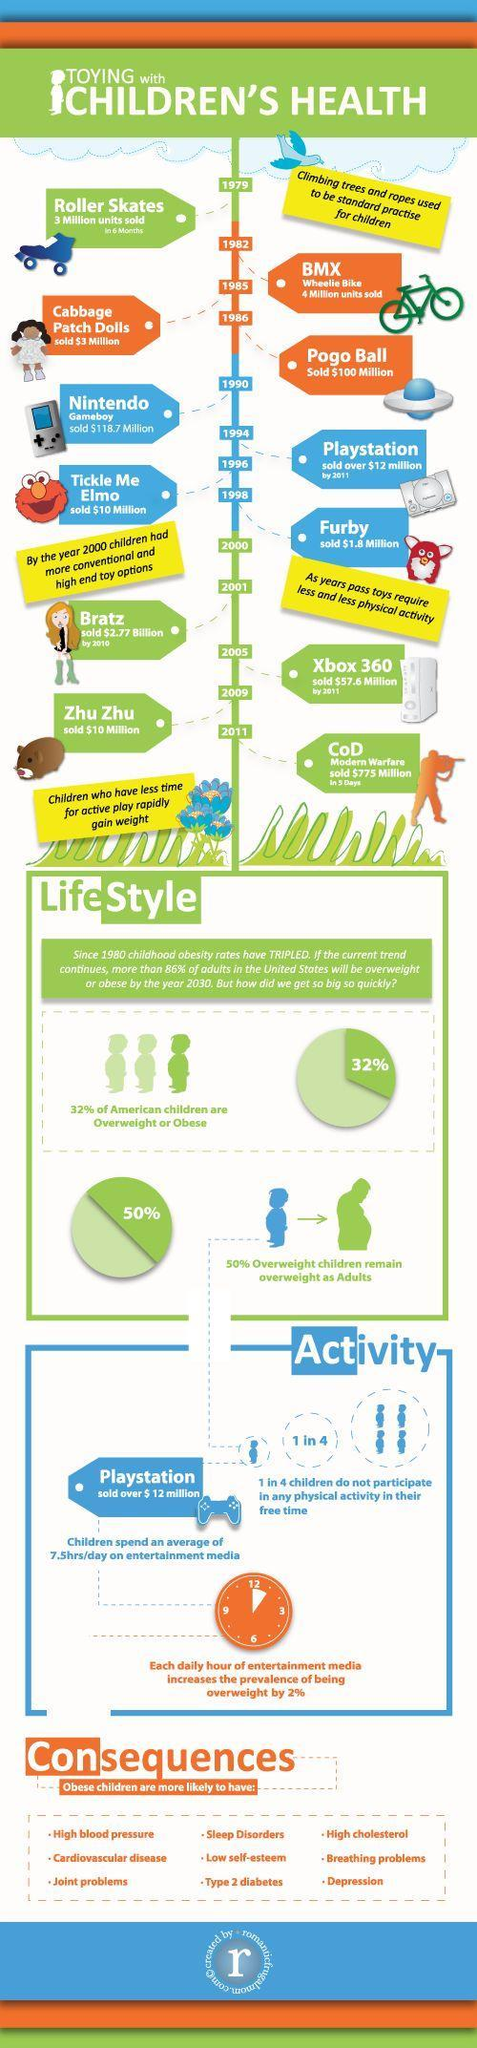What is the price of Furby?
Answer the question with a short phrase. $1.8 million Out of 4, how many children participate in any physical activity in their free time? 3 What percentage of American children are not overweight? 68% 